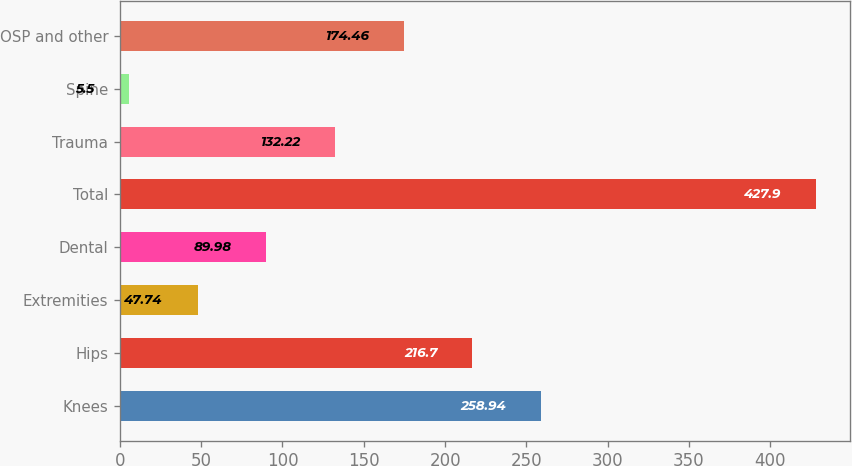Convert chart. <chart><loc_0><loc_0><loc_500><loc_500><bar_chart><fcel>Knees<fcel>Hips<fcel>Extremities<fcel>Dental<fcel>Total<fcel>Trauma<fcel>Spine<fcel>OSP and other<nl><fcel>258.94<fcel>216.7<fcel>47.74<fcel>89.98<fcel>427.9<fcel>132.22<fcel>5.5<fcel>174.46<nl></chart> 